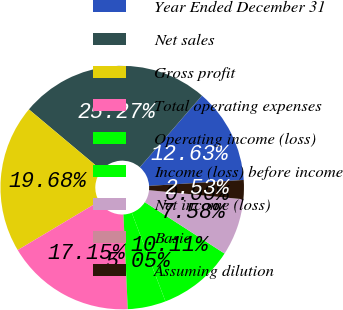Convert chart to OTSL. <chart><loc_0><loc_0><loc_500><loc_500><pie_chart><fcel>Year Ended December 31<fcel>Net sales<fcel>Gross profit<fcel>Total operating expenses<fcel>Operating income (loss)<fcel>Income (loss) before income<fcel>Net income (loss)<fcel>Basic<fcel>Assuming dilution<nl><fcel>12.63%<fcel>25.27%<fcel>19.68%<fcel>17.15%<fcel>5.05%<fcel>10.11%<fcel>7.58%<fcel>0.0%<fcel>2.53%<nl></chart> 